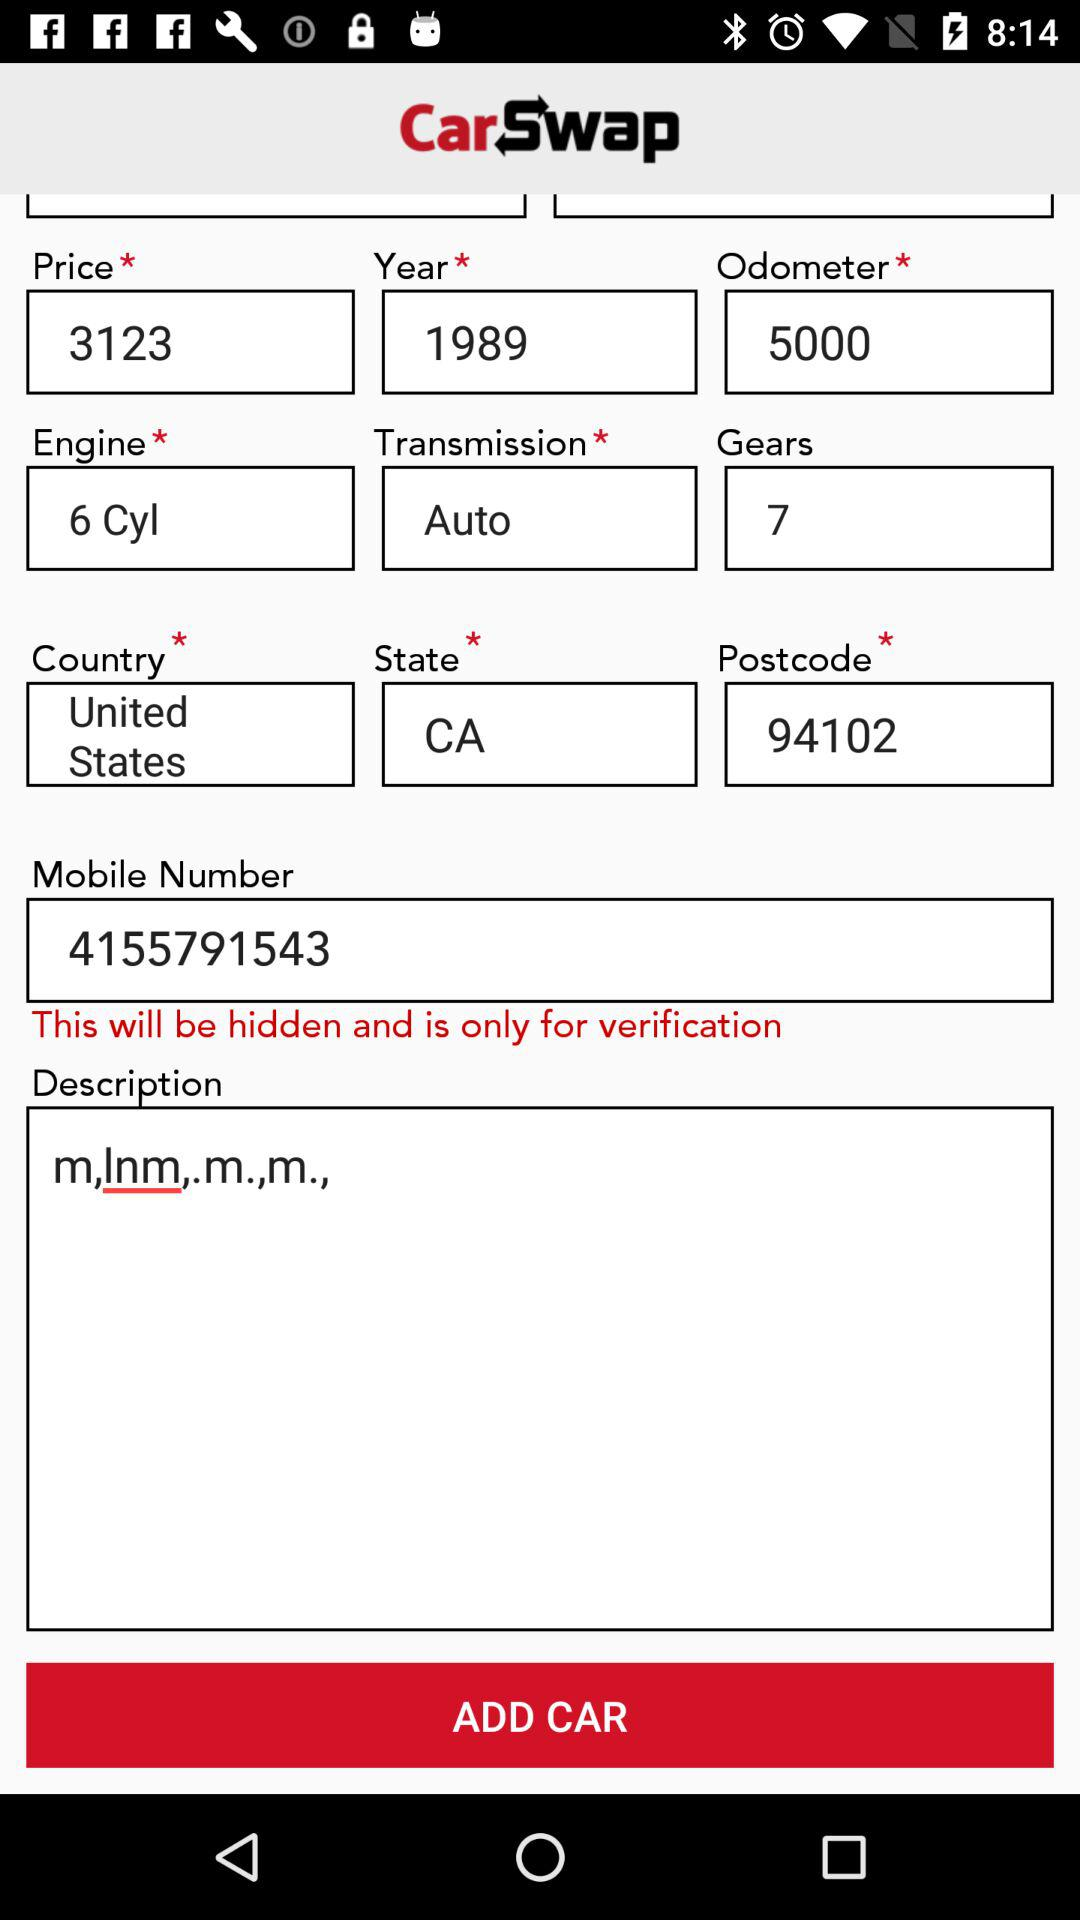How many miles does the car have on it?
Answer the question using a single word or phrase. 5000 